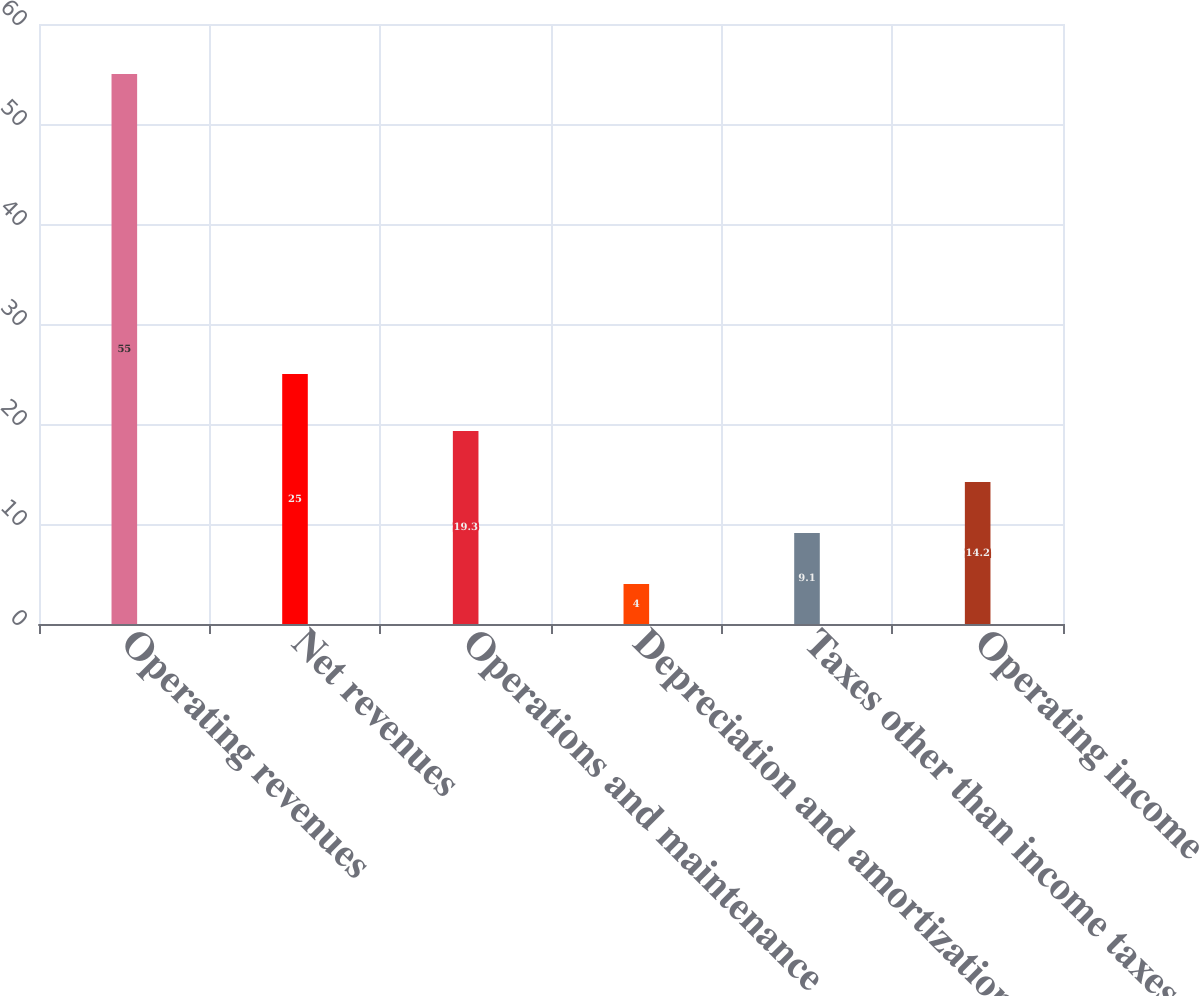Convert chart to OTSL. <chart><loc_0><loc_0><loc_500><loc_500><bar_chart><fcel>Operating revenues<fcel>Net revenues<fcel>Operations and maintenance<fcel>Depreciation and amortization<fcel>Taxes other than income taxes<fcel>Operating income<nl><fcel>55<fcel>25<fcel>19.3<fcel>4<fcel>9.1<fcel>14.2<nl></chart> 